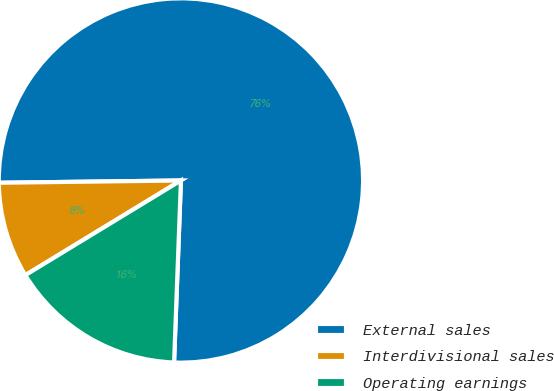Convert chart to OTSL. <chart><loc_0><loc_0><loc_500><loc_500><pie_chart><fcel>External sales<fcel>Interdivisional sales<fcel>Operating earnings<nl><fcel>75.8%<fcel>8.5%<fcel>15.7%<nl></chart> 